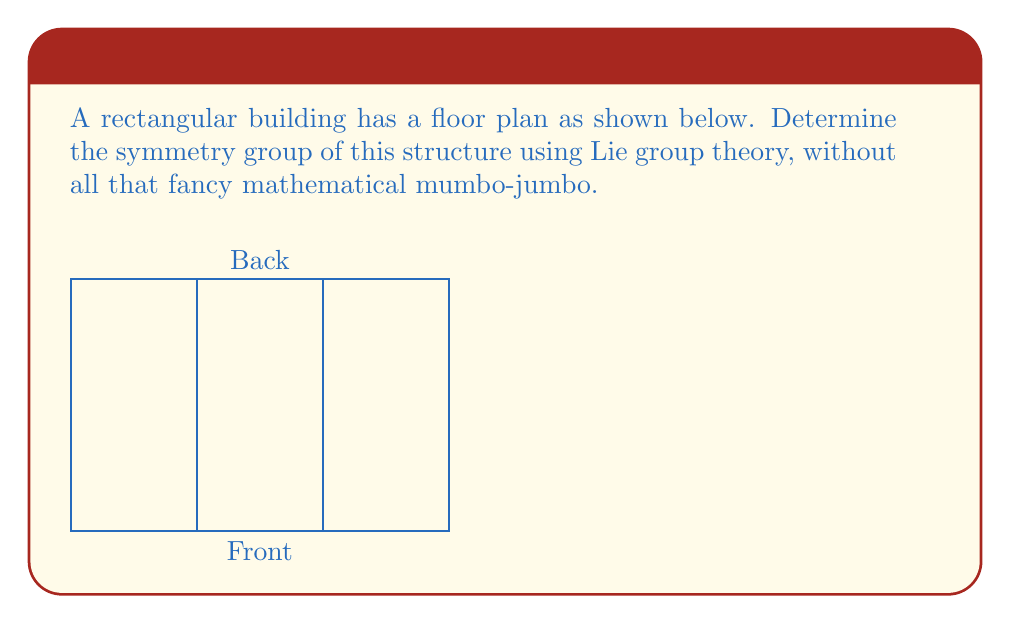Can you solve this math problem? Alright, let's cut through the jargon and look at this practically:

1. First, we need to identify the symmetries this building has:
   - It can be flipped left to right (reflection across the vertical axis)
   - It can be rotated 180 degrees (rotation around the center)

2. In plain English, these symmetries form what's called the Dihedral group of order 2, or $D_2$.

3. Now, to connect this to Lie group theory without getting too technical:
   - $D_2$ is a discrete subgroup of the continuous rotation group $SO(2)$
   - $SO(2)$ is a one-dimensional Lie group (it's just rotations in a plane)

4. The Lie algebra associated with $SO(2)$ is just the real numbers $\mathbb{R}$ with the trivial Lie bracket $[x,y] = 0$

5. Our building's symmetry group $D_2$ corresponds to the discrete subgroup of $SO(2)$ generated by the rotation:
   $$ R = \begin{pmatrix} -1 & 0 \\ 0 & -1 \end{pmatrix} $$

6. In the Lie algebra, this corresponds to the element $\pi$ in $\mathbb{R}$, as $e^{\pi J} = R$ where $J = \begin{pmatrix} 0 & -1 \\ 1 & 0 \end{pmatrix}$

So, in essence, the building's symmetry is captured by a simple rotation and reflection, which can be described using a small part of a larger, continuous symmetry group.
Answer: $D_2$, a discrete subgroup of $SO(2)$ 